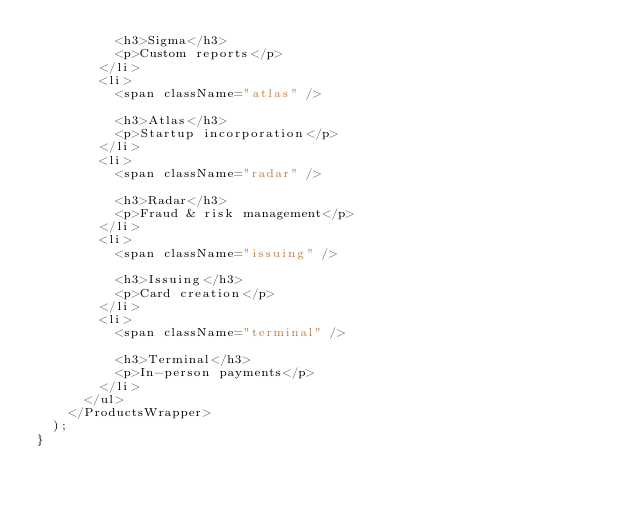Convert code to text. <code><loc_0><loc_0><loc_500><loc_500><_JavaScript_>          <h3>Sigma</h3>
          <p>Custom reports</p>
        </li>
        <li>
          <span className="atlas" />

          <h3>Atlas</h3>
          <p>Startup incorporation</p>
        </li>
        <li>
          <span className="radar" />

          <h3>Radar</h3>
          <p>Fraud & risk management</p>
        </li>
        <li>
          <span className="issuing" />

          <h3>Issuing</h3>
          <p>Card creation</p>
        </li>
        <li>
          <span className="terminal" />

          <h3>Terminal</h3>
          <p>In-person payments</p>
        </li>
      </ul>
    </ProductsWrapper>
  );
}
</code> 